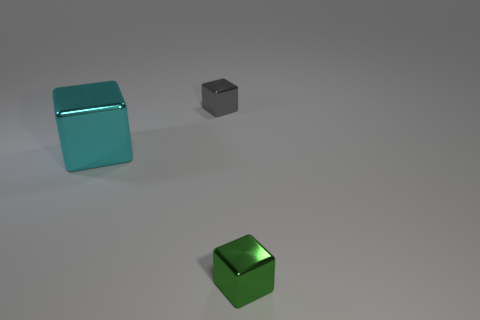Is the shape of the tiny green metallic object the same as the gray metallic object?
Offer a very short reply. Yes. What number of shiny blocks are in front of the tiny metal object on the left side of the green metal block?
Provide a succinct answer. 2. Is the number of blocks that are on the right side of the large metal block greater than the number of large metallic blocks on the right side of the gray cube?
Make the answer very short. Yes. What material is the green cube?
Your answer should be very brief. Metal. Are there any shiny objects of the same size as the gray metal cube?
Provide a short and direct response. Yes. How many large yellow matte cylinders are there?
Your answer should be very brief. 0. What size is the object that is on the right side of the small gray metal thing?
Provide a succinct answer. Small. Are there an equal number of small gray objects that are in front of the green metal object and small gray shiny cubes?
Your answer should be compact. No. Is there another small metallic object that has the same shape as the cyan shiny thing?
Provide a short and direct response. Yes. What shape is the metallic object that is both behind the tiny green metal block and to the right of the cyan object?
Ensure brevity in your answer.  Cube. 